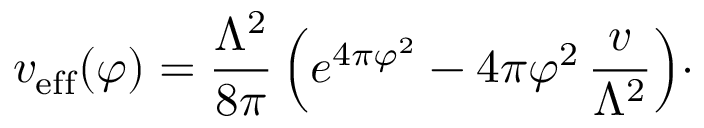<formula> <loc_0><loc_0><loc_500><loc_500>v _ { e f f } ( \varphi ) = { \frac { \Lambda ^ { 2 } } { 8 \pi } } \, \left ( e ^ { 4 \pi \varphi ^ { 2 } } - 4 \pi \varphi ^ { 2 } \, { \frac { v } { \Lambda ^ { 2 } } } \right ) \cdot</formula> 